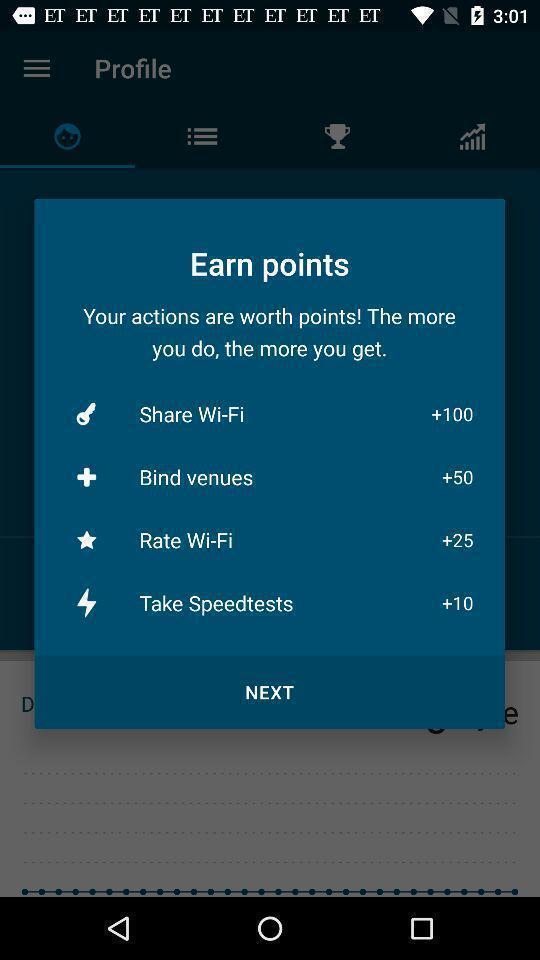Give me a summary of this screen capture. Popup showing earn points with various options. 